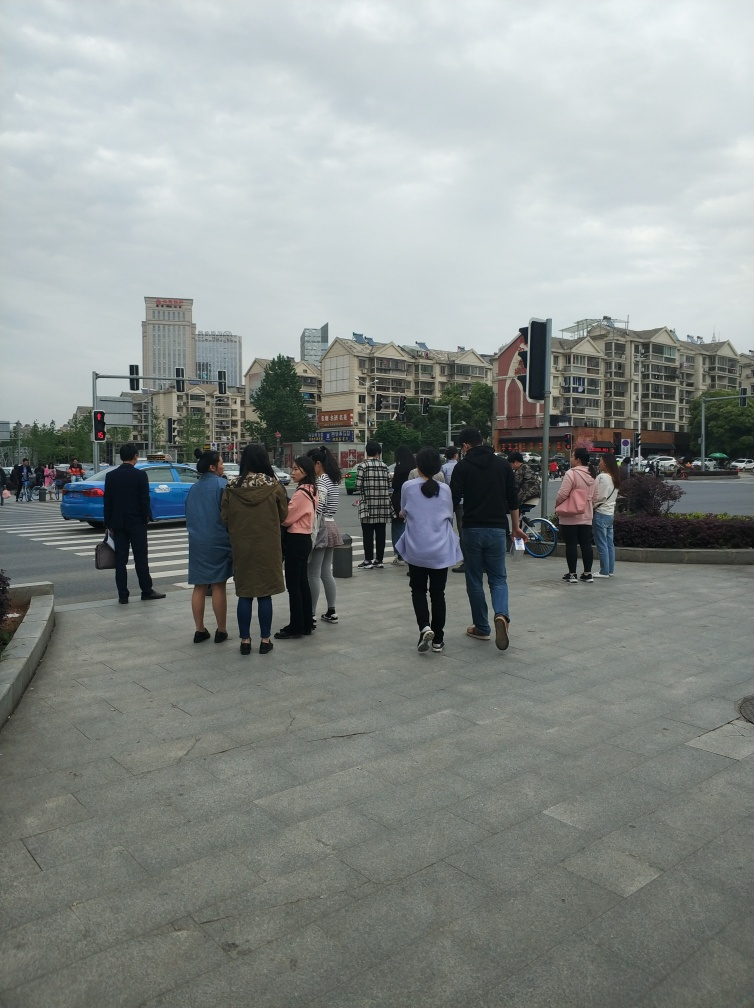Could you estimate the time of day this photo was taken? Given the overcast sky and the lighting, it is difficult to determine the precise time of day, but the amount of people and active traffic suggest it could be during typical daytime hours, perhaps late morning or afternoon. 